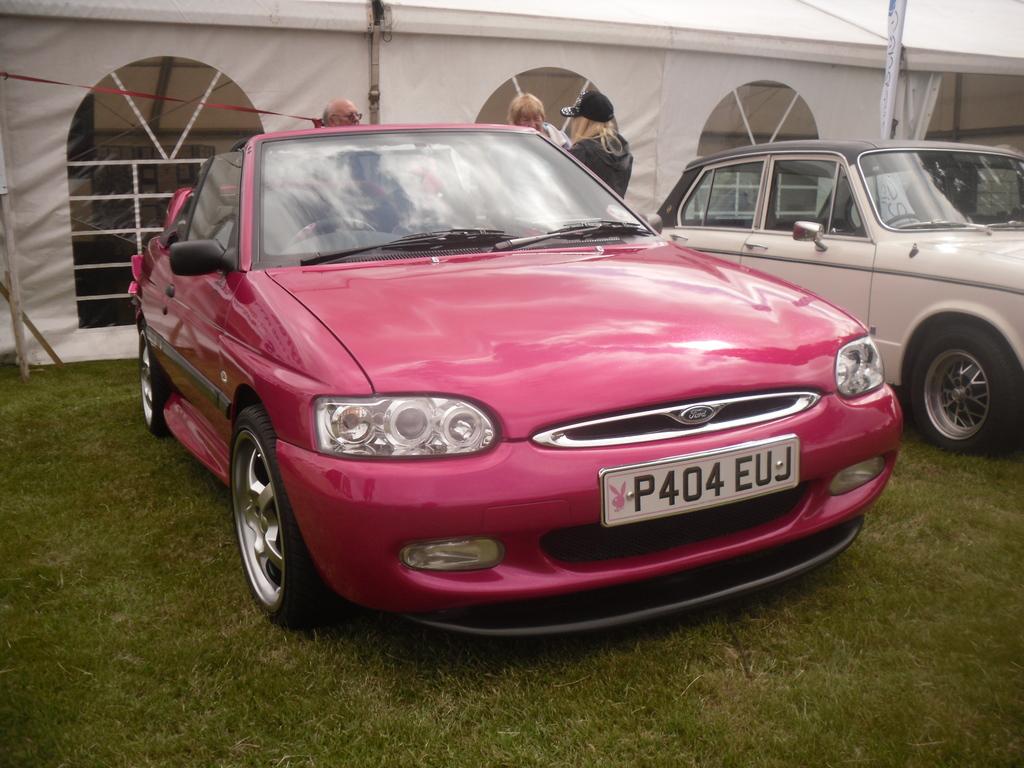What does the license plate say?
Offer a terse response. P404euj. Who manufacturers this car?
Keep it short and to the point. Ford. 